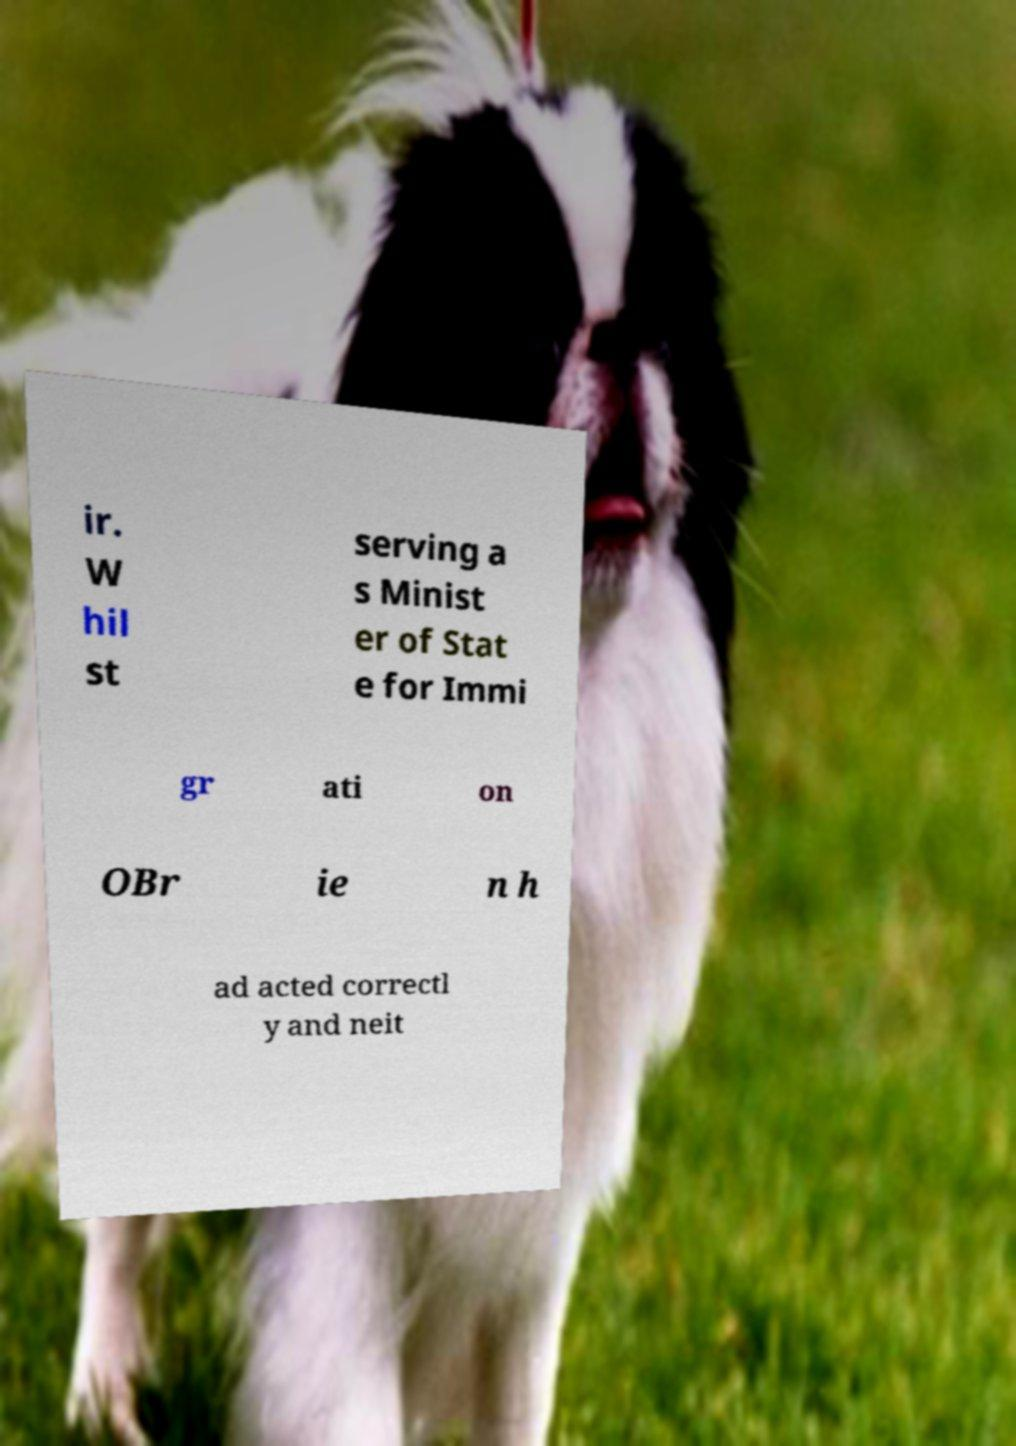Can you read and provide the text displayed in the image?This photo seems to have some interesting text. Can you extract and type it out for me? ir. W hil st serving a s Minist er of Stat e for Immi gr ati on OBr ie n h ad acted correctl y and neit 